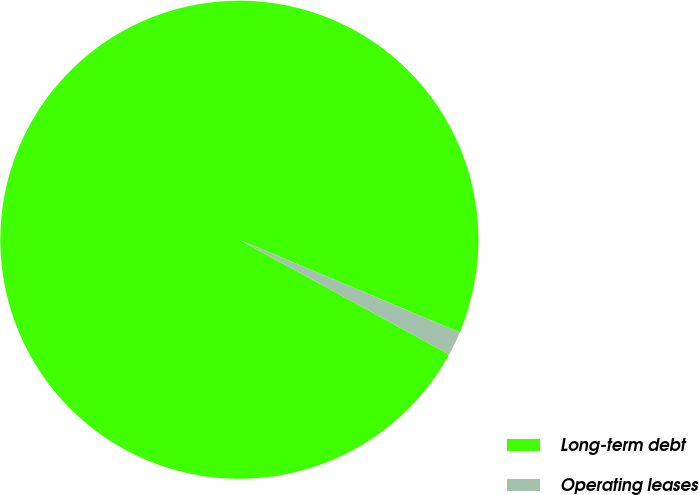Convert chart. <chart><loc_0><loc_0><loc_500><loc_500><pie_chart><fcel>Long-term debt<fcel>Operating leases<nl><fcel>98.37%<fcel>1.63%<nl></chart> 